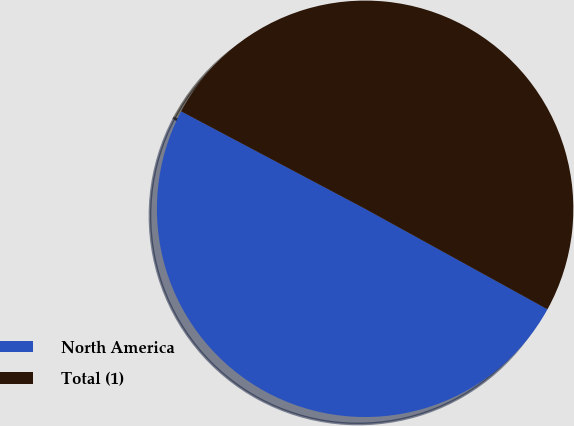<chart> <loc_0><loc_0><loc_500><loc_500><pie_chart><fcel>North America<fcel>Total (1)<nl><fcel>49.74%<fcel>50.26%<nl></chart> 